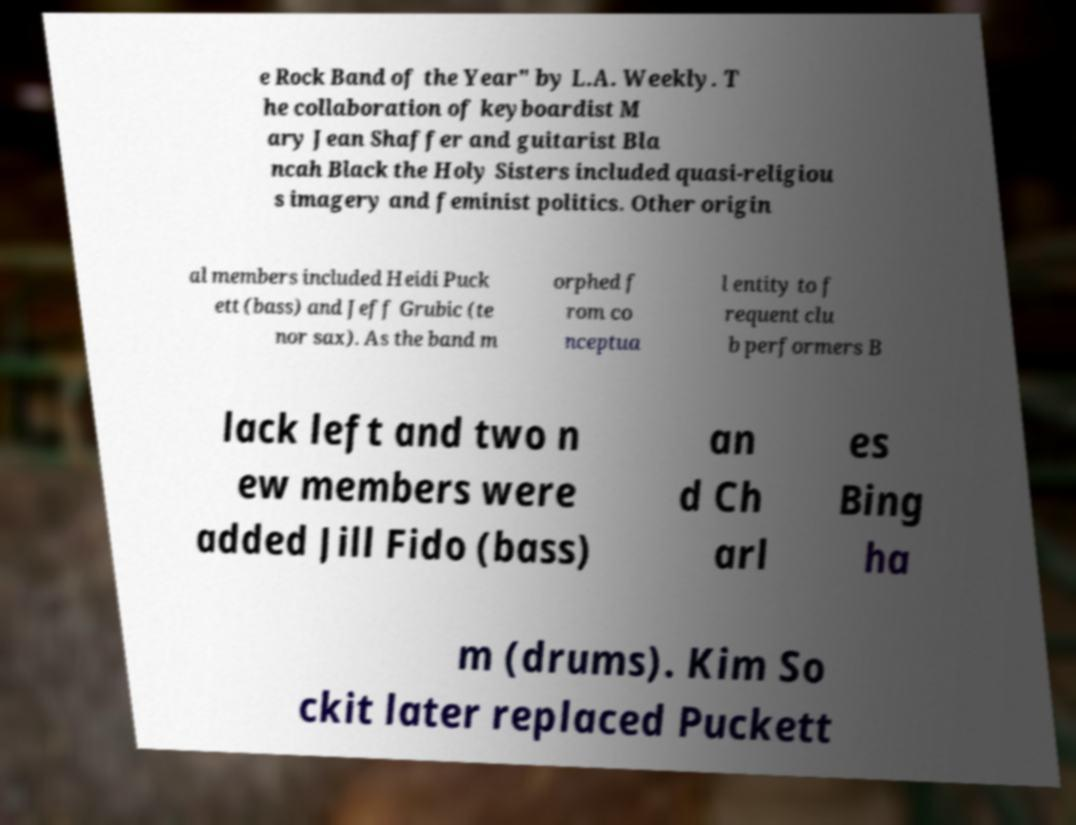For documentation purposes, I need the text within this image transcribed. Could you provide that? e Rock Band of the Year" by L.A. Weekly. T he collaboration of keyboardist M ary Jean Shaffer and guitarist Bla ncah Black the Holy Sisters included quasi-religiou s imagery and feminist politics. Other origin al members included Heidi Puck ett (bass) and Jeff Grubic (te nor sax). As the band m orphed f rom co nceptua l entity to f requent clu b performers B lack left and two n ew members were added Jill Fido (bass) an d Ch arl es Bing ha m (drums). Kim So ckit later replaced Puckett 